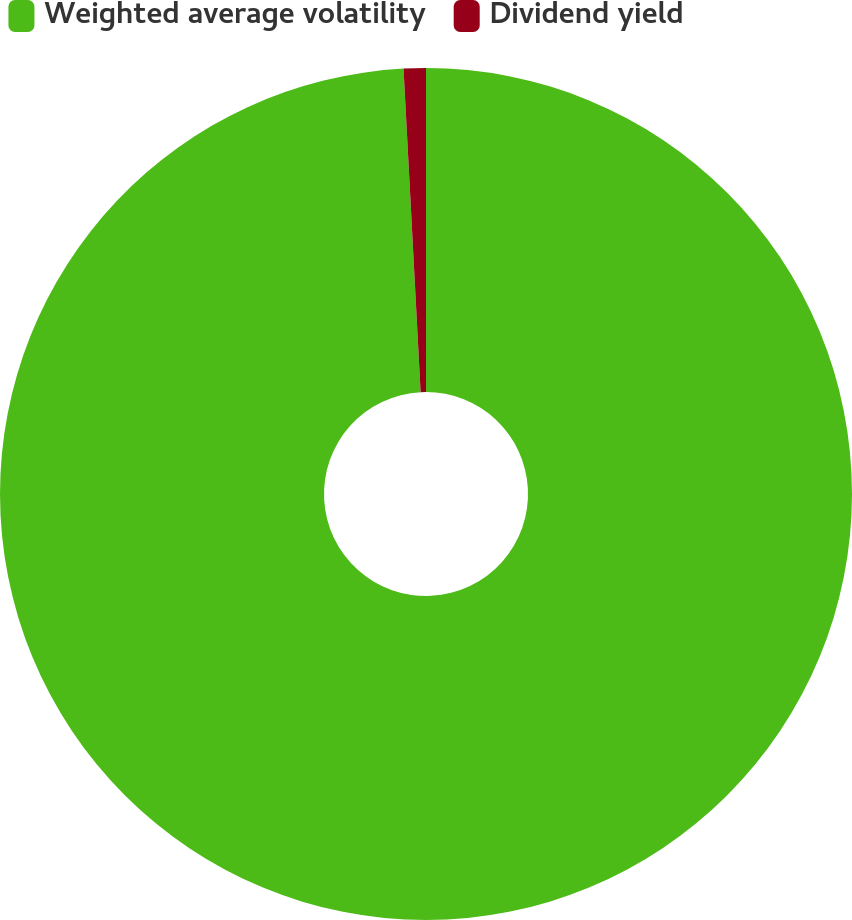<chart> <loc_0><loc_0><loc_500><loc_500><pie_chart><fcel>Weighted average volatility<fcel>Dividend yield<nl><fcel>99.16%<fcel>0.84%<nl></chart> 